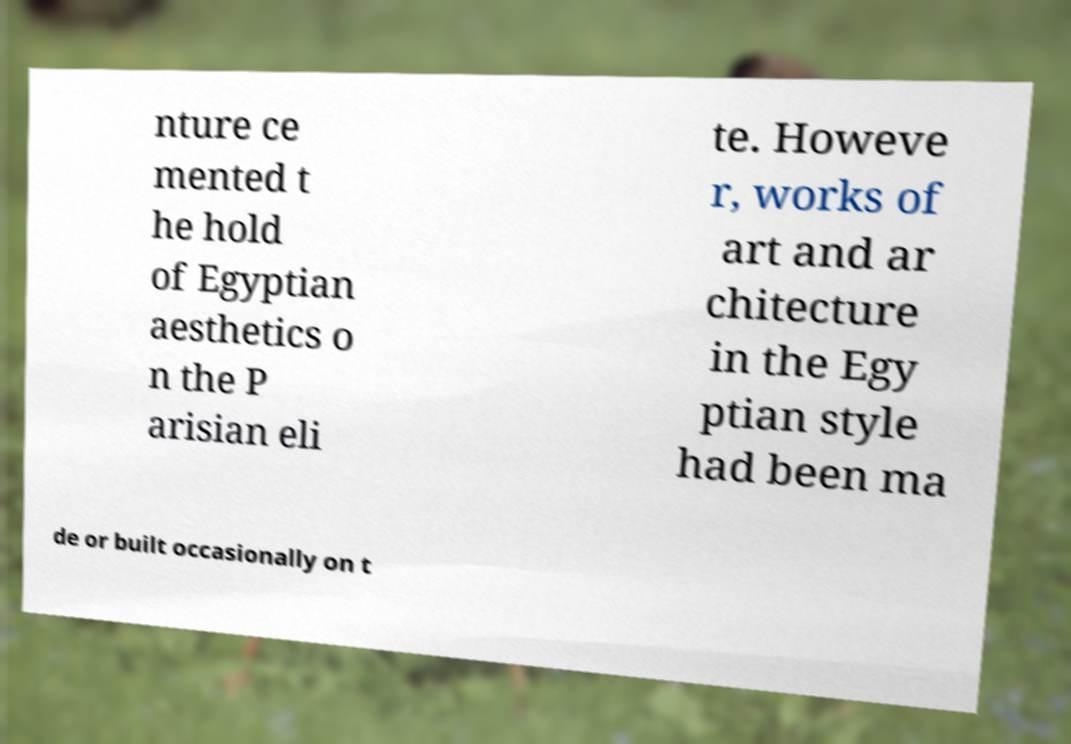Can you read and provide the text displayed in the image?This photo seems to have some interesting text. Can you extract and type it out for me? nture ce mented t he hold of Egyptian aesthetics o n the P arisian eli te. Howeve r, works of art and ar chitecture in the Egy ptian style had been ma de or built occasionally on t 